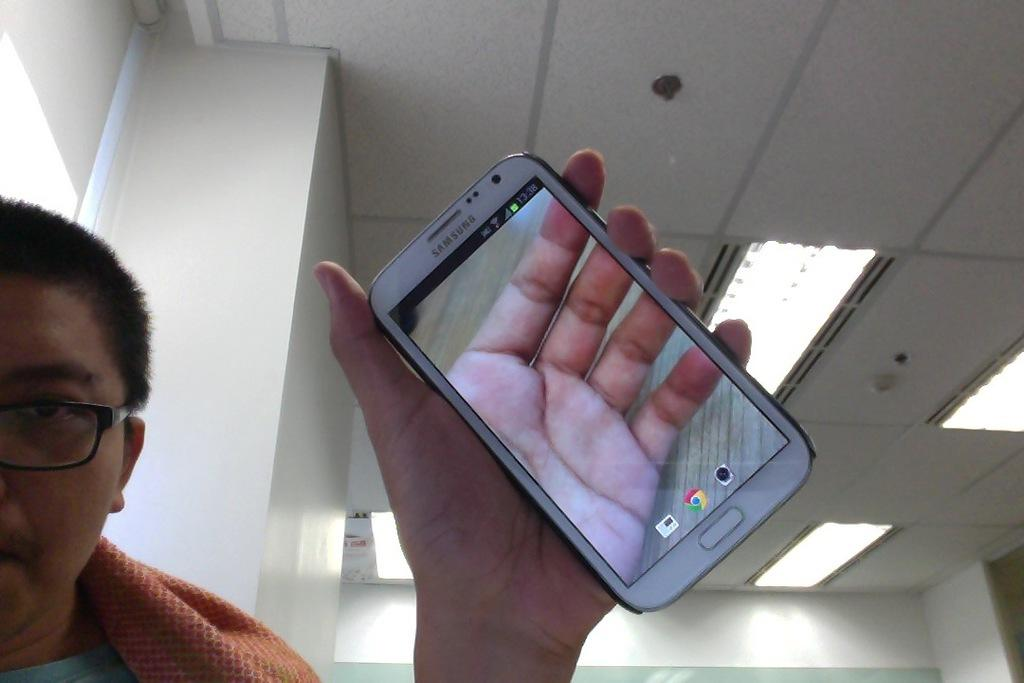Where was the image taken? The image was taken in a room. What is the person on the left side of the image doing? The person is sitting on the left side of the image and holding a mobile phone. What can be seen on the top of the image? There are lights visible on the top of the image. What type of activity is the manager performing with the farmer in the image? There is no manager or farmer present in the image, so no such activity can be observed. 